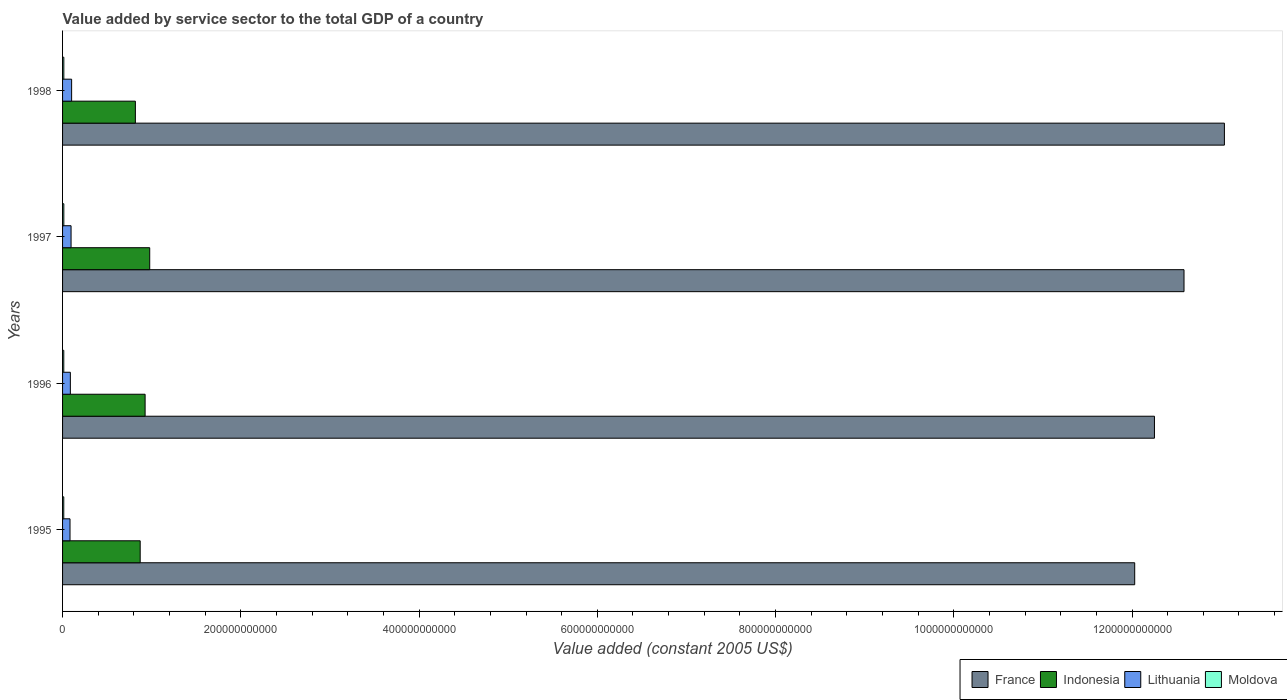How many different coloured bars are there?
Your response must be concise. 4. How many groups of bars are there?
Provide a short and direct response. 4. Are the number of bars per tick equal to the number of legend labels?
Your answer should be very brief. Yes. How many bars are there on the 4th tick from the top?
Keep it short and to the point. 4. What is the value added by service sector in Indonesia in 1998?
Make the answer very short. 8.17e+1. Across all years, what is the maximum value added by service sector in Lithuania?
Your answer should be very brief. 1.02e+1. Across all years, what is the minimum value added by service sector in Lithuania?
Your answer should be compact. 8.37e+09. In which year was the value added by service sector in Indonesia maximum?
Offer a terse response. 1997. In which year was the value added by service sector in Lithuania minimum?
Provide a succinct answer. 1995. What is the total value added by service sector in France in the graph?
Your answer should be very brief. 4.99e+12. What is the difference between the value added by service sector in Lithuania in 1995 and that in 1997?
Your answer should be compact. -1.17e+09. What is the difference between the value added by service sector in France in 1996 and the value added by service sector in Lithuania in 1995?
Make the answer very short. 1.22e+12. What is the average value added by service sector in France per year?
Your answer should be very brief. 1.25e+12. In the year 1997, what is the difference between the value added by service sector in Indonesia and value added by service sector in Moldova?
Offer a terse response. 9.64e+1. What is the ratio of the value added by service sector in Lithuania in 1995 to that in 1998?
Make the answer very short. 0.82. What is the difference between the highest and the second highest value added by service sector in France?
Your answer should be very brief. 4.53e+1. What is the difference between the highest and the lowest value added by service sector in Lithuania?
Offer a terse response. 1.80e+09. In how many years, is the value added by service sector in Moldova greater than the average value added by service sector in Moldova taken over all years?
Provide a succinct answer. 2. What does the 1st bar from the top in 1996 represents?
Ensure brevity in your answer.  Moldova. What does the 3rd bar from the bottom in 1997 represents?
Offer a very short reply. Lithuania. Are all the bars in the graph horizontal?
Keep it short and to the point. Yes. How many years are there in the graph?
Provide a succinct answer. 4. What is the difference between two consecutive major ticks on the X-axis?
Keep it short and to the point. 2.00e+11. Are the values on the major ticks of X-axis written in scientific E-notation?
Offer a terse response. No. Does the graph contain grids?
Provide a short and direct response. No. How many legend labels are there?
Offer a very short reply. 4. How are the legend labels stacked?
Make the answer very short. Horizontal. What is the title of the graph?
Give a very brief answer. Value added by service sector to the total GDP of a country. What is the label or title of the X-axis?
Make the answer very short. Value added (constant 2005 US$). What is the label or title of the Y-axis?
Your answer should be very brief. Years. What is the Value added (constant 2005 US$) of France in 1995?
Provide a succinct answer. 1.20e+12. What is the Value added (constant 2005 US$) of Indonesia in 1995?
Your answer should be very brief. 8.71e+1. What is the Value added (constant 2005 US$) of Lithuania in 1995?
Keep it short and to the point. 8.37e+09. What is the Value added (constant 2005 US$) in Moldova in 1995?
Offer a very short reply. 1.35e+09. What is the Value added (constant 2005 US$) of France in 1996?
Provide a succinct answer. 1.23e+12. What is the Value added (constant 2005 US$) in Indonesia in 1996?
Give a very brief answer. 9.26e+1. What is the Value added (constant 2005 US$) of Lithuania in 1996?
Your answer should be very brief. 8.74e+09. What is the Value added (constant 2005 US$) in Moldova in 1996?
Offer a very short reply. 1.37e+09. What is the Value added (constant 2005 US$) in France in 1997?
Your response must be concise. 1.26e+12. What is the Value added (constant 2005 US$) in Indonesia in 1997?
Make the answer very short. 9.78e+1. What is the Value added (constant 2005 US$) in Lithuania in 1997?
Keep it short and to the point. 9.54e+09. What is the Value added (constant 2005 US$) of Moldova in 1997?
Ensure brevity in your answer.  1.41e+09. What is the Value added (constant 2005 US$) of France in 1998?
Your answer should be compact. 1.30e+12. What is the Value added (constant 2005 US$) of Indonesia in 1998?
Your answer should be compact. 8.17e+1. What is the Value added (constant 2005 US$) in Lithuania in 1998?
Ensure brevity in your answer.  1.02e+1. What is the Value added (constant 2005 US$) of Moldova in 1998?
Your answer should be compact. 1.42e+09. Across all years, what is the maximum Value added (constant 2005 US$) in France?
Give a very brief answer. 1.30e+12. Across all years, what is the maximum Value added (constant 2005 US$) in Indonesia?
Your response must be concise. 9.78e+1. Across all years, what is the maximum Value added (constant 2005 US$) in Lithuania?
Ensure brevity in your answer.  1.02e+1. Across all years, what is the maximum Value added (constant 2005 US$) of Moldova?
Provide a short and direct response. 1.42e+09. Across all years, what is the minimum Value added (constant 2005 US$) in France?
Make the answer very short. 1.20e+12. Across all years, what is the minimum Value added (constant 2005 US$) of Indonesia?
Offer a terse response. 8.17e+1. Across all years, what is the minimum Value added (constant 2005 US$) of Lithuania?
Offer a terse response. 8.37e+09. Across all years, what is the minimum Value added (constant 2005 US$) in Moldova?
Give a very brief answer. 1.35e+09. What is the total Value added (constant 2005 US$) of France in the graph?
Your answer should be compact. 4.99e+12. What is the total Value added (constant 2005 US$) of Indonesia in the graph?
Your response must be concise. 3.59e+11. What is the total Value added (constant 2005 US$) of Lithuania in the graph?
Your answer should be very brief. 3.68e+1. What is the total Value added (constant 2005 US$) in Moldova in the graph?
Provide a short and direct response. 5.54e+09. What is the difference between the Value added (constant 2005 US$) of France in 1995 and that in 1996?
Give a very brief answer. -2.22e+1. What is the difference between the Value added (constant 2005 US$) in Indonesia in 1995 and that in 1996?
Make the answer very short. -5.52e+09. What is the difference between the Value added (constant 2005 US$) in Lithuania in 1995 and that in 1996?
Your response must be concise. -3.79e+08. What is the difference between the Value added (constant 2005 US$) of Moldova in 1995 and that in 1996?
Give a very brief answer. -1.85e+07. What is the difference between the Value added (constant 2005 US$) of France in 1995 and that in 1997?
Provide a succinct answer. -5.53e+1. What is the difference between the Value added (constant 2005 US$) of Indonesia in 1995 and that in 1997?
Your answer should be very brief. -1.07e+1. What is the difference between the Value added (constant 2005 US$) in Lithuania in 1995 and that in 1997?
Keep it short and to the point. -1.17e+09. What is the difference between the Value added (constant 2005 US$) in Moldova in 1995 and that in 1997?
Your answer should be compact. -5.96e+07. What is the difference between the Value added (constant 2005 US$) of France in 1995 and that in 1998?
Provide a short and direct response. -1.01e+11. What is the difference between the Value added (constant 2005 US$) of Indonesia in 1995 and that in 1998?
Give a very brief answer. 5.40e+09. What is the difference between the Value added (constant 2005 US$) in Lithuania in 1995 and that in 1998?
Provide a succinct answer. -1.80e+09. What is the difference between the Value added (constant 2005 US$) of Moldova in 1995 and that in 1998?
Your response must be concise. -7.05e+07. What is the difference between the Value added (constant 2005 US$) of France in 1996 and that in 1997?
Offer a very short reply. -3.32e+1. What is the difference between the Value added (constant 2005 US$) of Indonesia in 1996 and that in 1997?
Offer a terse response. -5.17e+09. What is the difference between the Value added (constant 2005 US$) in Lithuania in 1996 and that in 1997?
Ensure brevity in your answer.  -7.93e+08. What is the difference between the Value added (constant 2005 US$) of Moldova in 1996 and that in 1997?
Your answer should be compact. -4.11e+07. What is the difference between the Value added (constant 2005 US$) of France in 1996 and that in 1998?
Your answer should be very brief. -7.85e+1. What is the difference between the Value added (constant 2005 US$) in Indonesia in 1996 and that in 1998?
Make the answer very short. 1.09e+1. What is the difference between the Value added (constant 2005 US$) in Lithuania in 1996 and that in 1998?
Your answer should be compact. -1.42e+09. What is the difference between the Value added (constant 2005 US$) of Moldova in 1996 and that in 1998?
Provide a short and direct response. -5.21e+07. What is the difference between the Value added (constant 2005 US$) of France in 1997 and that in 1998?
Your answer should be compact. -4.53e+1. What is the difference between the Value added (constant 2005 US$) of Indonesia in 1997 and that in 1998?
Offer a very short reply. 1.61e+1. What is the difference between the Value added (constant 2005 US$) in Lithuania in 1997 and that in 1998?
Keep it short and to the point. -6.29e+08. What is the difference between the Value added (constant 2005 US$) of Moldova in 1997 and that in 1998?
Give a very brief answer. -1.09e+07. What is the difference between the Value added (constant 2005 US$) in France in 1995 and the Value added (constant 2005 US$) in Indonesia in 1996?
Your response must be concise. 1.11e+12. What is the difference between the Value added (constant 2005 US$) of France in 1995 and the Value added (constant 2005 US$) of Lithuania in 1996?
Your answer should be very brief. 1.19e+12. What is the difference between the Value added (constant 2005 US$) in France in 1995 and the Value added (constant 2005 US$) in Moldova in 1996?
Your answer should be very brief. 1.20e+12. What is the difference between the Value added (constant 2005 US$) of Indonesia in 1995 and the Value added (constant 2005 US$) of Lithuania in 1996?
Your answer should be compact. 7.84e+1. What is the difference between the Value added (constant 2005 US$) of Indonesia in 1995 and the Value added (constant 2005 US$) of Moldova in 1996?
Your answer should be very brief. 8.57e+1. What is the difference between the Value added (constant 2005 US$) in Lithuania in 1995 and the Value added (constant 2005 US$) in Moldova in 1996?
Ensure brevity in your answer.  7.00e+09. What is the difference between the Value added (constant 2005 US$) of France in 1995 and the Value added (constant 2005 US$) of Indonesia in 1997?
Offer a terse response. 1.11e+12. What is the difference between the Value added (constant 2005 US$) in France in 1995 and the Value added (constant 2005 US$) in Lithuania in 1997?
Your answer should be very brief. 1.19e+12. What is the difference between the Value added (constant 2005 US$) of France in 1995 and the Value added (constant 2005 US$) of Moldova in 1997?
Offer a terse response. 1.20e+12. What is the difference between the Value added (constant 2005 US$) of Indonesia in 1995 and the Value added (constant 2005 US$) of Lithuania in 1997?
Offer a terse response. 7.76e+1. What is the difference between the Value added (constant 2005 US$) of Indonesia in 1995 and the Value added (constant 2005 US$) of Moldova in 1997?
Ensure brevity in your answer.  8.57e+1. What is the difference between the Value added (constant 2005 US$) in Lithuania in 1995 and the Value added (constant 2005 US$) in Moldova in 1997?
Ensure brevity in your answer.  6.96e+09. What is the difference between the Value added (constant 2005 US$) of France in 1995 and the Value added (constant 2005 US$) of Indonesia in 1998?
Offer a terse response. 1.12e+12. What is the difference between the Value added (constant 2005 US$) in France in 1995 and the Value added (constant 2005 US$) in Lithuania in 1998?
Your answer should be very brief. 1.19e+12. What is the difference between the Value added (constant 2005 US$) of France in 1995 and the Value added (constant 2005 US$) of Moldova in 1998?
Your answer should be compact. 1.20e+12. What is the difference between the Value added (constant 2005 US$) of Indonesia in 1995 and the Value added (constant 2005 US$) of Lithuania in 1998?
Your response must be concise. 7.69e+1. What is the difference between the Value added (constant 2005 US$) in Indonesia in 1995 and the Value added (constant 2005 US$) in Moldova in 1998?
Offer a very short reply. 8.57e+1. What is the difference between the Value added (constant 2005 US$) in Lithuania in 1995 and the Value added (constant 2005 US$) in Moldova in 1998?
Make the answer very short. 6.95e+09. What is the difference between the Value added (constant 2005 US$) of France in 1996 and the Value added (constant 2005 US$) of Indonesia in 1997?
Offer a very short reply. 1.13e+12. What is the difference between the Value added (constant 2005 US$) in France in 1996 and the Value added (constant 2005 US$) in Lithuania in 1997?
Your answer should be very brief. 1.22e+12. What is the difference between the Value added (constant 2005 US$) in France in 1996 and the Value added (constant 2005 US$) in Moldova in 1997?
Provide a short and direct response. 1.22e+12. What is the difference between the Value added (constant 2005 US$) of Indonesia in 1996 and the Value added (constant 2005 US$) of Lithuania in 1997?
Offer a very short reply. 8.31e+1. What is the difference between the Value added (constant 2005 US$) in Indonesia in 1996 and the Value added (constant 2005 US$) in Moldova in 1997?
Keep it short and to the point. 9.12e+1. What is the difference between the Value added (constant 2005 US$) of Lithuania in 1996 and the Value added (constant 2005 US$) of Moldova in 1997?
Offer a terse response. 7.34e+09. What is the difference between the Value added (constant 2005 US$) of France in 1996 and the Value added (constant 2005 US$) of Indonesia in 1998?
Your answer should be very brief. 1.14e+12. What is the difference between the Value added (constant 2005 US$) of France in 1996 and the Value added (constant 2005 US$) of Lithuania in 1998?
Your answer should be compact. 1.22e+12. What is the difference between the Value added (constant 2005 US$) of France in 1996 and the Value added (constant 2005 US$) of Moldova in 1998?
Your answer should be very brief. 1.22e+12. What is the difference between the Value added (constant 2005 US$) in Indonesia in 1996 and the Value added (constant 2005 US$) in Lithuania in 1998?
Keep it short and to the point. 8.25e+1. What is the difference between the Value added (constant 2005 US$) in Indonesia in 1996 and the Value added (constant 2005 US$) in Moldova in 1998?
Provide a succinct answer. 9.12e+1. What is the difference between the Value added (constant 2005 US$) in Lithuania in 1996 and the Value added (constant 2005 US$) in Moldova in 1998?
Make the answer very short. 7.33e+09. What is the difference between the Value added (constant 2005 US$) of France in 1997 and the Value added (constant 2005 US$) of Indonesia in 1998?
Offer a terse response. 1.18e+12. What is the difference between the Value added (constant 2005 US$) in France in 1997 and the Value added (constant 2005 US$) in Lithuania in 1998?
Give a very brief answer. 1.25e+12. What is the difference between the Value added (constant 2005 US$) of France in 1997 and the Value added (constant 2005 US$) of Moldova in 1998?
Offer a very short reply. 1.26e+12. What is the difference between the Value added (constant 2005 US$) in Indonesia in 1997 and the Value added (constant 2005 US$) in Lithuania in 1998?
Your response must be concise. 8.76e+1. What is the difference between the Value added (constant 2005 US$) of Indonesia in 1997 and the Value added (constant 2005 US$) of Moldova in 1998?
Your answer should be very brief. 9.64e+1. What is the difference between the Value added (constant 2005 US$) in Lithuania in 1997 and the Value added (constant 2005 US$) in Moldova in 1998?
Your response must be concise. 8.12e+09. What is the average Value added (constant 2005 US$) of France per year?
Your response must be concise. 1.25e+12. What is the average Value added (constant 2005 US$) of Indonesia per year?
Give a very brief answer. 8.98e+1. What is the average Value added (constant 2005 US$) in Lithuania per year?
Make the answer very short. 9.20e+09. What is the average Value added (constant 2005 US$) of Moldova per year?
Your answer should be compact. 1.39e+09. In the year 1995, what is the difference between the Value added (constant 2005 US$) of France and Value added (constant 2005 US$) of Indonesia?
Provide a succinct answer. 1.12e+12. In the year 1995, what is the difference between the Value added (constant 2005 US$) in France and Value added (constant 2005 US$) in Lithuania?
Your answer should be very brief. 1.19e+12. In the year 1995, what is the difference between the Value added (constant 2005 US$) of France and Value added (constant 2005 US$) of Moldova?
Provide a short and direct response. 1.20e+12. In the year 1995, what is the difference between the Value added (constant 2005 US$) in Indonesia and Value added (constant 2005 US$) in Lithuania?
Offer a terse response. 7.87e+1. In the year 1995, what is the difference between the Value added (constant 2005 US$) in Indonesia and Value added (constant 2005 US$) in Moldova?
Your answer should be very brief. 8.57e+1. In the year 1995, what is the difference between the Value added (constant 2005 US$) of Lithuania and Value added (constant 2005 US$) of Moldova?
Make the answer very short. 7.02e+09. In the year 1996, what is the difference between the Value added (constant 2005 US$) of France and Value added (constant 2005 US$) of Indonesia?
Provide a succinct answer. 1.13e+12. In the year 1996, what is the difference between the Value added (constant 2005 US$) in France and Value added (constant 2005 US$) in Lithuania?
Make the answer very short. 1.22e+12. In the year 1996, what is the difference between the Value added (constant 2005 US$) in France and Value added (constant 2005 US$) in Moldova?
Your answer should be very brief. 1.22e+12. In the year 1996, what is the difference between the Value added (constant 2005 US$) in Indonesia and Value added (constant 2005 US$) in Lithuania?
Provide a succinct answer. 8.39e+1. In the year 1996, what is the difference between the Value added (constant 2005 US$) of Indonesia and Value added (constant 2005 US$) of Moldova?
Make the answer very short. 9.13e+1. In the year 1996, what is the difference between the Value added (constant 2005 US$) in Lithuania and Value added (constant 2005 US$) in Moldova?
Provide a short and direct response. 7.38e+09. In the year 1997, what is the difference between the Value added (constant 2005 US$) of France and Value added (constant 2005 US$) of Indonesia?
Keep it short and to the point. 1.16e+12. In the year 1997, what is the difference between the Value added (constant 2005 US$) of France and Value added (constant 2005 US$) of Lithuania?
Provide a short and direct response. 1.25e+12. In the year 1997, what is the difference between the Value added (constant 2005 US$) of France and Value added (constant 2005 US$) of Moldova?
Your response must be concise. 1.26e+12. In the year 1997, what is the difference between the Value added (constant 2005 US$) of Indonesia and Value added (constant 2005 US$) of Lithuania?
Your response must be concise. 8.83e+1. In the year 1997, what is the difference between the Value added (constant 2005 US$) in Indonesia and Value added (constant 2005 US$) in Moldova?
Keep it short and to the point. 9.64e+1. In the year 1997, what is the difference between the Value added (constant 2005 US$) of Lithuania and Value added (constant 2005 US$) of Moldova?
Keep it short and to the point. 8.13e+09. In the year 1998, what is the difference between the Value added (constant 2005 US$) in France and Value added (constant 2005 US$) in Indonesia?
Keep it short and to the point. 1.22e+12. In the year 1998, what is the difference between the Value added (constant 2005 US$) of France and Value added (constant 2005 US$) of Lithuania?
Offer a terse response. 1.29e+12. In the year 1998, what is the difference between the Value added (constant 2005 US$) of France and Value added (constant 2005 US$) of Moldova?
Offer a very short reply. 1.30e+12. In the year 1998, what is the difference between the Value added (constant 2005 US$) in Indonesia and Value added (constant 2005 US$) in Lithuania?
Keep it short and to the point. 7.15e+1. In the year 1998, what is the difference between the Value added (constant 2005 US$) in Indonesia and Value added (constant 2005 US$) in Moldova?
Your answer should be compact. 8.03e+1. In the year 1998, what is the difference between the Value added (constant 2005 US$) in Lithuania and Value added (constant 2005 US$) in Moldova?
Ensure brevity in your answer.  8.75e+09. What is the ratio of the Value added (constant 2005 US$) of France in 1995 to that in 1996?
Ensure brevity in your answer.  0.98. What is the ratio of the Value added (constant 2005 US$) of Indonesia in 1995 to that in 1996?
Offer a very short reply. 0.94. What is the ratio of the Value added (constant 2005 US$) of Lithuania in 1995 to that in 1996?
Make the answer very short. 0.96. What is the ratio of the Value added (constant 2005 US$) of Moldova in 1995 to that in 1996?
Provide a succinct answer. 0.99. What is the ratio of the Value added (constant 2005 US$) in France in 1995 to that in 1997?
Offer a terse response. 0.96. What is the ratio of the Value added (constant 2005 US$) of Indonesia in 1995 to that in 1997?
Your answer should be compact. 0.89. What is the ratio of the Value added (constant 2005 US$) of Lithuania in 1995 to that in 1997?
Offer a terse response. 0.88. What is the ratio of the Value added (constant 2005 US$) of Moldova in 1995 to that in 1997?
Make the answer very short. 0.96. What is the ratio of the Value added (constant 2005 US$) of France in 1995 to that in 1998?
Offer a very short reply. 0.92. What is the ratio of the Value added (constant 2005 US$) in Indonesia in 1995 to that in 1998?
Your response must be concise. 1.07. What is the ratio of the Value added (constant 2005 US$) in Lithuania in 1995 to that in 1998?
Your answer should be compact. 0.82. What is the ratio of the Value added (constant 2005 US$) of Moldova in 1995 to that in 1998?
Keep it short and to the point. 0.95. What is the ratio of the Value added (constant 2005 US$) of France in 1996 to that in 1997?
Offer a terse response. 0.97. What is the ratio of the Value added (constant 2005 US$) of Indonesia in 1996 to that in 1997?
Make the answer very short. 0.95. What is the ratio of the Value added (constant 2005 US$) in Lithuania in 1996 to that in 1997?
Your response must be concise. 0.92. What is the ratio of the Value added (constant 2005 US$) in Moldova in 1996 to that in 1997?
Offer a very short reply. 0.97. What is the ratio of the Value added (constant 2005 US$) in France in 1996 to that in 1998?
Offer a terse response. 0.94. What is the ratio of the Value added (constant 2005 US$) in Indonesia in 1996 to that in 1998?
Offer a terse response. 1.13. What is the ratio of the Value added (constant 2005 US$) in Lithuania in 1996 to that in 1998?
Provide a succinct answer. 0.86. What is the ratio of the Value added (constant 2005 US$) in Moldova in 1996 to that in 1998?
Offer a terse response. 0.96. What is the ratio of the Value added (constant 2005 US$) in France in 1997 to that in 1998?
Offer a very short reply. 0.97. What is the ratio of the Value added (constant 2005 US$) of Indonesia in 1997 to that in 1998?
Your response must be concise. 1.2. What is the ratio of the Value added (constant 2005 US$) of Lithuania in 1997 to that in 1998?
Keep it short and to the point. 0.94. What is the ratio of the Value added (constant 2005 US$) in Moldova in 1997 to that in 1998?
Your answer should be very brief. 0.99. What is the difference between the highest and the second highest Value added (constant 2005 US$) of France?
Make the answer very short. 4.53e+1. What is the difference between the highest and the second highest Value added (constant 2005 US$) in Indonesia?
Your answer should be very brief. 5.17e+09. What is the difference between the highest and the second highest Value added (constant 2005 US$) of Lithuania?
Your answer should be very brief. 6.29e+08. What is the difference between the highest and the second highest Value added (constant 2005 US$) of Moldova?
Ensure brevity in your answer.  1.09e+07. What is the difference between the highest and the lowest Value added (constant 2005 US$) in France?
Make the answer very short. 1.01e+11. What is the difference between the highest and the lowest Value added (constant 2005 US$) in Indonesia?
Your answer should be very brief. 1.61e+1. What is the difference between the highest and the lowest Value added (constant 2005 US$) in Lithuania?
Provide a short and direct response. 1.80e+09. What is the difference between the highest and the lowest Value added (constant 2005 US$) in Moldova?
Give a very brief answer. 7.05e+07. 